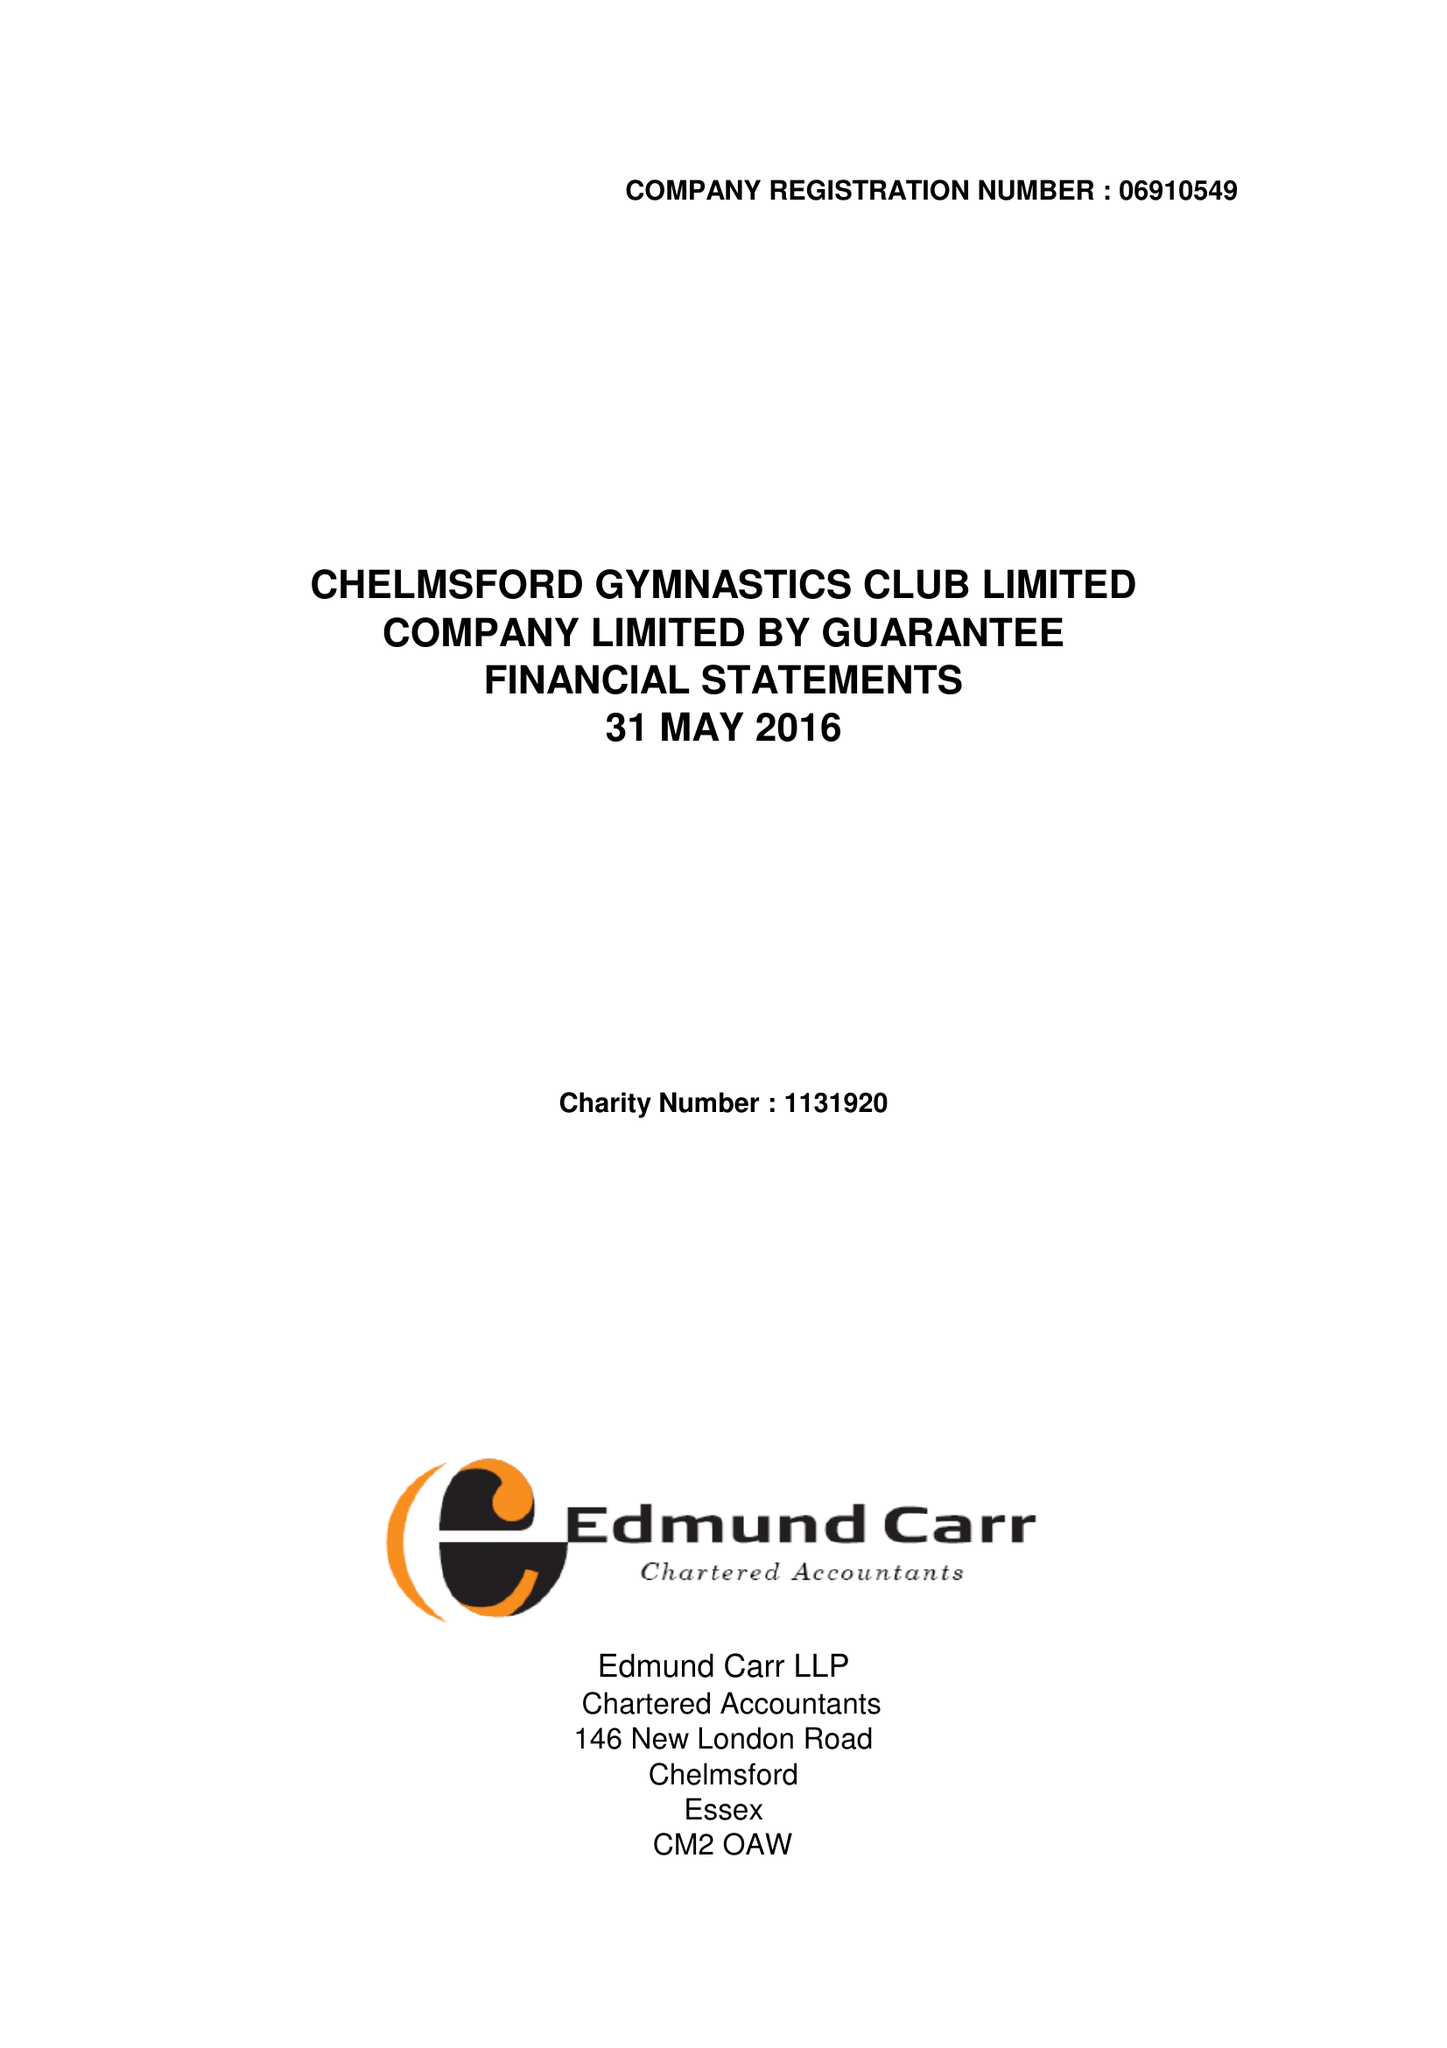What is the value for the report_date?
Answer the question using a single word or phrase. 2016-05-31 